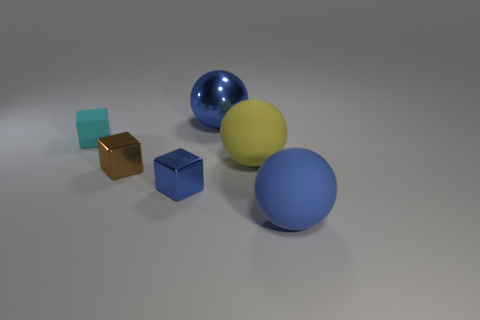What textures are visible in the objects within the image? The objects present a variety of textures. The spheres appear smooth and shiny, especially noticeable on the blue sphere. The cubes, on the other hand, seem to have a matte surface, which diffuses the light, giving them a softer appearance. How do the objects' textures contribute to the overall aesthetic of the image? The contrasting textures create a dynamic visual experience. The smoothness of the spheres reflects light and adds highlights, which draws the eye and provides a sense of depth. The matte cubes absorb light, providing balance and subtly complementing the spheres without overpowering them, resulting in a harmonious and appealing scene. 